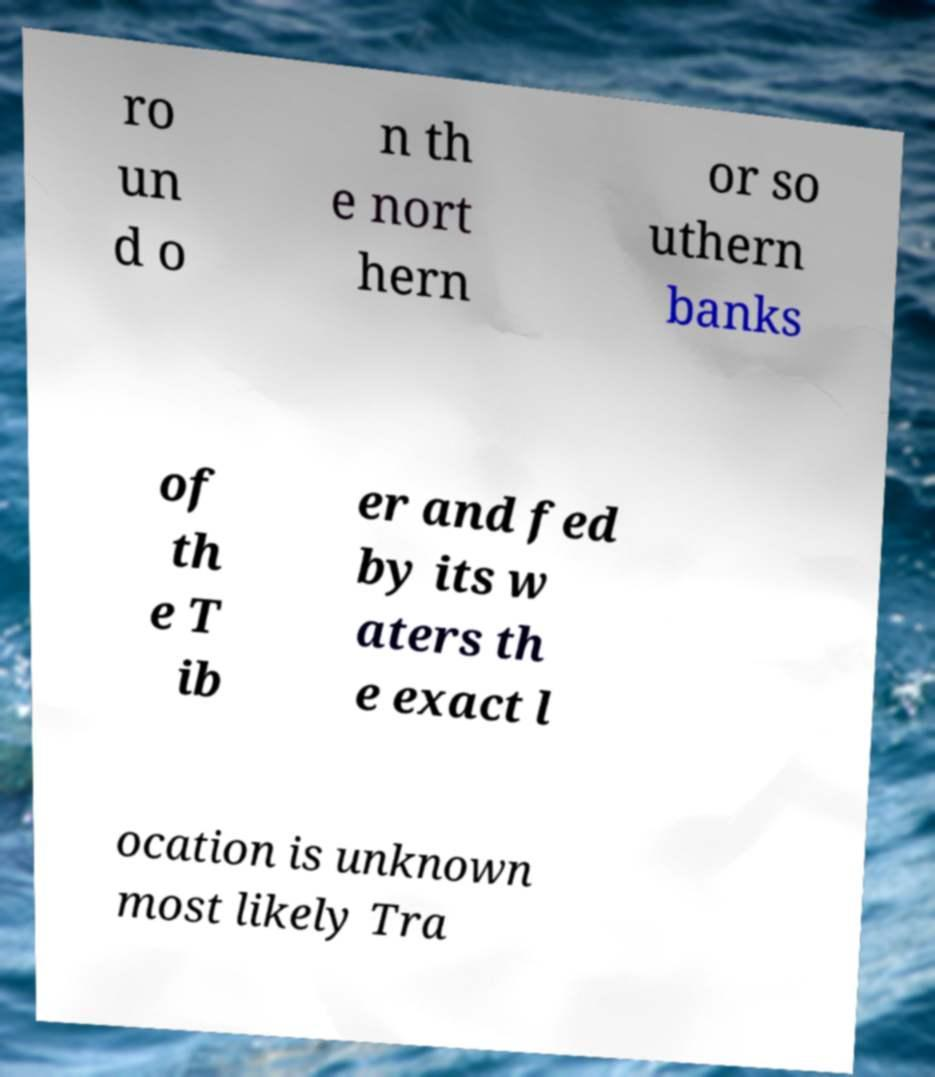There's text embedded in this image that I need extracted. Can you transcribe it verbatim? ro un d o n th e nort hern or so uthern banks of th e T ib er and fed by its w aters th e exact l ocation is unknown most likely Tra 